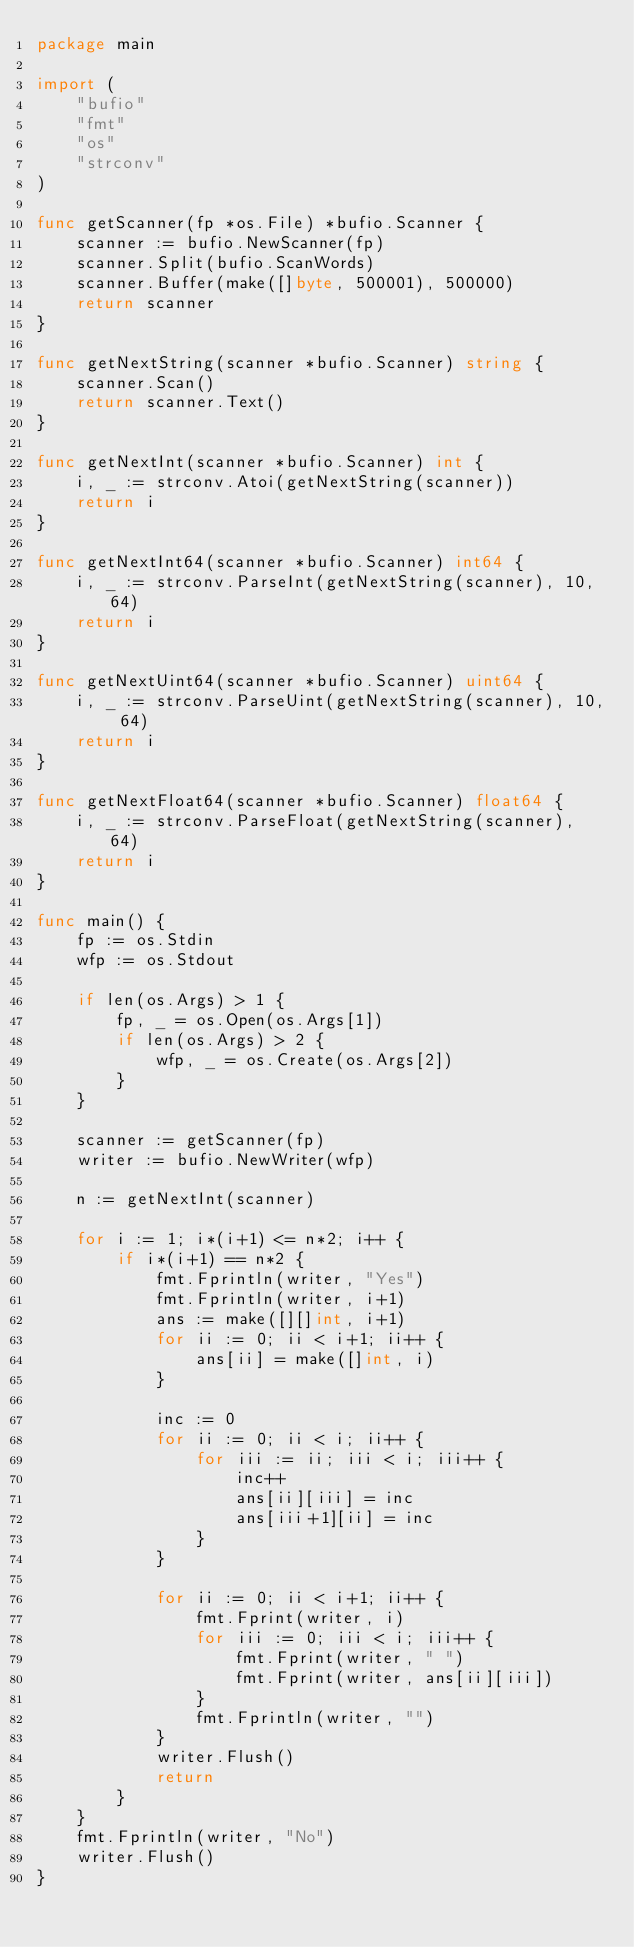Convert code to text. <code><loc_0><loc_0><loc_500><loc_500><_Go_>package main

import (
	"bufio"
	"fmt"
	"os"
	"strconv"
)

func getScanner(fp *os.File) *bufio.Scanner {
	scanner := bufio.NewScanner(fp)
	scanner.Split(bufio.ScanWords)
	scanner.Buffer(make([]byte, 500001), 500000)
	return scanner
}

func getNextString(scanner *bufio.Scanner) string {
	scanner.Scan()
	return scanner.Text()
}

func getNextInt(scanner *bufio.Scanner) int {
	i, _ := strconv.Atoi(getNextString(scanner))
	return i
}

func getNextInt64(scanner *bufio.Scanner) int64 {
	i, _ := strconv.ParseInt(getNextString(scanner), 10, 64)
	return i
}

func getNextUint64(scanner *bufio.Scanner) uint64 {
	i, _ := strconv.ParseUint(getNextString(scanner), 10, 64)
	return i
}

func getNextFloat64(scanner *bufio.Scanner) float64 {
	i, _ := strconv.ParseFloat(getNextString(scanner), 64)
	return i
}

func main() {
	fp := os.Stdin
	wfp := os.Stdout

	if len(os.Args) > 1 {
		fp, _ = os.Open(os.Args[1])
		if len(os.Args) > 2 {
			wfp, _ = os.Create(os.Args[2])
		}
	}

	scanner := getScanner(fp)
	writer := bufio.NewWriter(wfp)

	n := getNextInt(scanner)

	for i := 1; i*(i+1) <= n*2; i++ {
		if i*(i+1) == n*2 {
			fmt.Fprintln(writer, "Yes")
			fmt.Fprintln(writer, i+1)
			ans := make([][]int, i+1)
			for ii := 0; ii < i+1; ii++ {
				ans[ii] = make([]int, i)
			}

			inc := 0
			for ii := 0; ii < i; ii++ {
				for iii := ii; iii < i; iii++ {
					inc++
					ans[ii][iii] = inc
					ans[iii+1][ii] = inc
				}
			}

			for ii := 0; ii < i+1; ii++ {
				fmt.Fprint(writer, i)
				for iii := 0; iii < i; iii++ {
					fmt.Fprint(writer, " ")
					fmt.Fprint(writer, ans[ii][iii])
				}
				fmt.Fprintln(writer, "")
			}
			writer.Flush()
			return
		}
	}
	fmt.Fprintln(writer, "No")
	writer.Flush()
}
</code> 